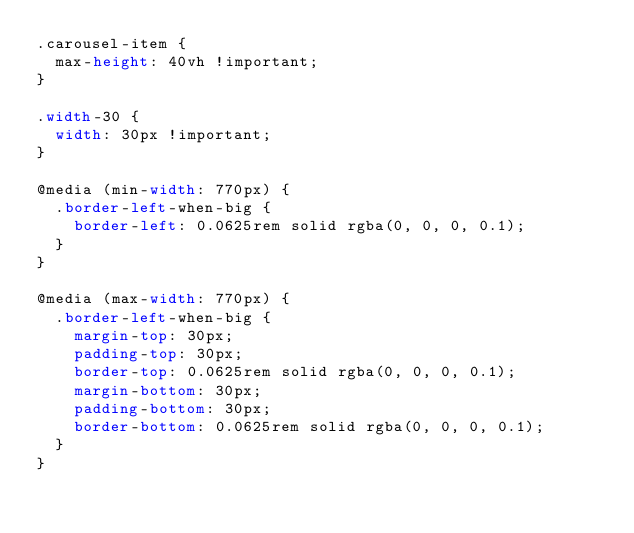<code> <loc_0><loc_0><loc_500><loc_500><_CSS_>.carousel-item {
  max-height: 40vh !important;
}

.width-30 {
  width: 30px !important;
}

@media (min-width: 770px) {
  .border-left-when-big {
    border-left: 0.0625rem solid rgba(0, 0, 0, 0.1);
  }
}

@media (max-width: 770px) {
  .border-left-when-big {
    margin-top: 30px;
    padding-top: 30px;
    border-top: 0.0625rem solid rgba(0, 0, 0, 0.1);
    margin-bottom: 30px;
    padding-bottom: 30px;
    border-bottom: 0.0625rem solid rgba(0, 0, 0, 0.1);
  }
}</code> 